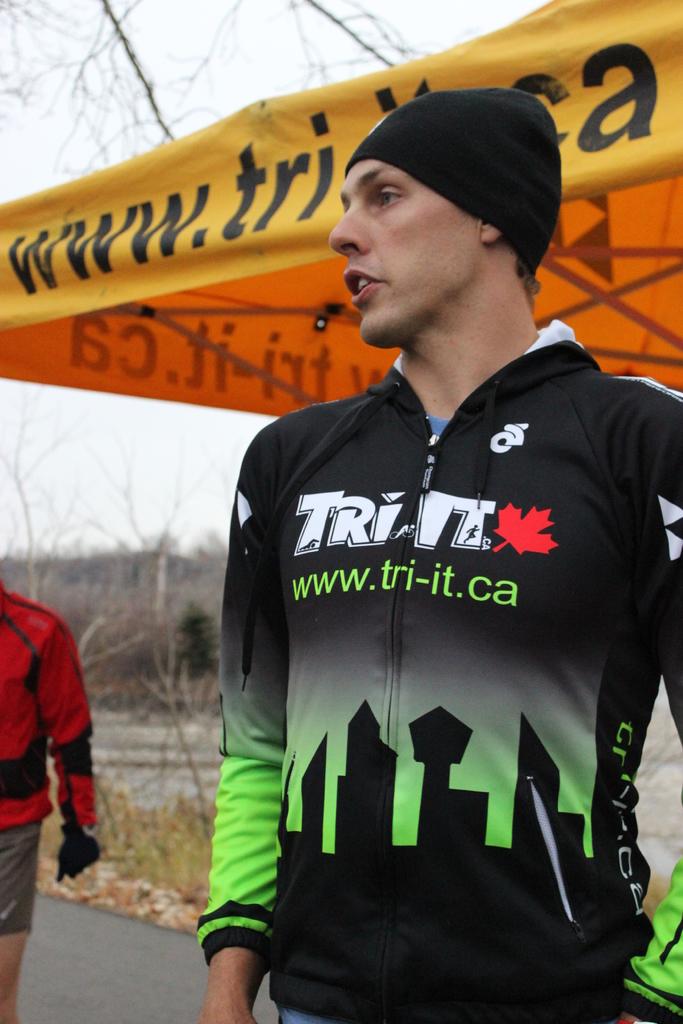In what country does the triathlon take place?
Ensure brevity in your answer.  Canada. 